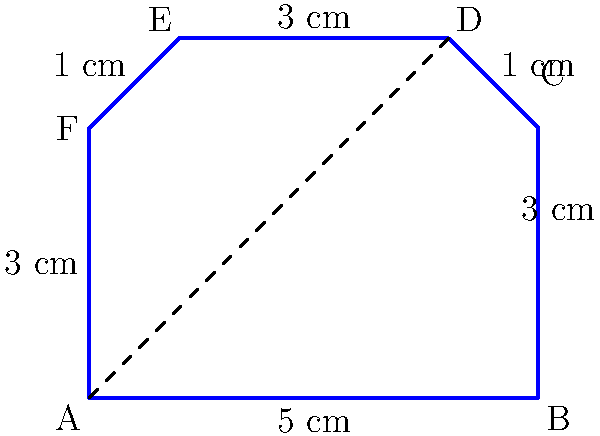In your literary-themed home office, you've decided to create a custom bookshelf in the shape of an open book. The shelf's dimensions are represented by the polygon ABCDEF in the diagram. If the length AB is 5 cm and the height AF is 3 cm, what is the total area of this book-shaped shelf in square centimeters? To find the area of this irregular polygon, we can divide it into simpler shapes:

1. Rectangle ABCF:
   Area = length × width = 5 cm × 3 cm = 15 cm²

2. Triangle CDE:
   Base (CD) = 1 cm
   Height = 1 cm (difference between heights of D and C)
   Area = $\frac{1}{2}$ × base × height = $\frac{1}{2}$ × 1 cm × 1 cm = 0.5 cm²

3. Rectangle CDEF:
   Length (EF) = 3 cm
   Width (DE - CF) = 1 cm
   Area = 3 cm × 1 cm = 3 cm²

Total area:
$$ \text{Total Area} = \text{Area}_{\text{ABCF}} + \text{Area}_{\text{CDE}} + \text{Area}_{\text{CDEF}} $$
$$ \text{Total Area} = 15 \text{ cm}^2 + 0.5 \text{ cm}^2 + 3 \text{ cm}^2 = 18.5 \text{ cm}^2 $$
Answer: 18.5 cm² 